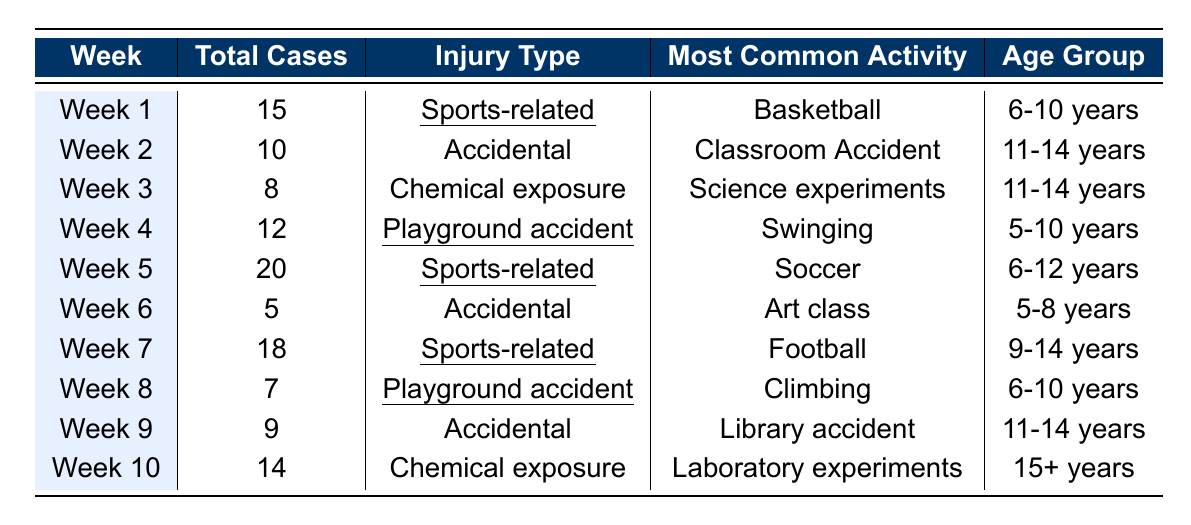What was the total number of eye injuries reported in Week 5? From the table, the number of total cases in Week 5 is listed directly as 20.
Answer: 20 Which injury type had the highest incidence? The highest total cases in the table are for Sports-related injuries in Weeks 1 (15 cases), 5 (20 cases), and 7 (18 cases). Therefore, Sports-related has the highest incidence with a total of 53 cases.
Answer: Sports-related What is the most common activity associated with chemical exposure injuries? The table shows that the most common activities related to chemical exposure injuries are 'Science experiments' in Week 3 and 'Laboratory experiments' in Week 10.
Answer: Science experiments and Laboratory experiments How many cases of accidental eye injuries were reported in total? To find the total, we can sum the cases listed under the 'Accidental' injury type in Weeks 2, 6, and 9, which are 10, 5, and 9 respectively. The total is 10 + 5 + 9 = 24.
Answer: 24 Which age group had the most cases of sports-related injuries, and how many were there? By examining the table, we see that the age groups 6-10 years (15 cases in Week 1), 6-12 years (20 cases in Week 5), and 9-14 years (18 cases in Week 7) had sports-related injuries. The total for these age groups is 15 + 20 + 18 = 53. Therefore, the most affected age group is 6-12 years, with 20 cases from Week 5.
Answer: 6-12 years with 20 cases What percentage of the total cases in Week 4 were related to playground accidents? The total cases in Week 4 is 12, and all those cases are from playground accidents. To find the percentage, we can calculate (12 / 12) * 100 = 100%.
Answer: 100% Is there a week with zero cases reported, and if so, which week is it? The table does not indicate a week with zero reported cases; every week has at least one case listed.
Answer: No, every week has reported cases How do the total cases related to playground accidents compare to those related to sports-related injuries? Playground accidents totaled 12 (Week 4 + Week 8), while sports-related injuries totaled 53 (Week 1 + Week 5 + Week 7). 53 is greater than 12, indicating that sports-related injuries are more common.
Answer: Sports-related injuries (53) are greater than playground accidents (12) What is the average number of eye injuries reported each week? There are 10 weeks of data; we sum the total cases: 15 + 10 + 8 + 12 + 20 + 5 + 18 + 7 + 9 + 14 = 118. The average is 118 / 10 = 11.8.
Answer: 11.8 Which week had the least number of total cases, and what was the number? The week with the least reported cases is Week 6 with 5 total cases.
Answer: Week 6 with 5 cases In which age group do most eye injuries happen according to this data? The age groups represented are 5-8 years (Week 6), 5-10 years (Week 4), 6-10 years (Weeks 1 and 8), 6-12 years (Week 5), 9-14 years (Weeks 2 and 7), and 11-14 years (Weeks 2 and 9). The most reported cases appear to come from 6-10 years and 9-14 years with a total of 15 + 12 + 20 + 18 = 65 cases.
Answer: 6-10 years and 9-14 years with 65 cases total 